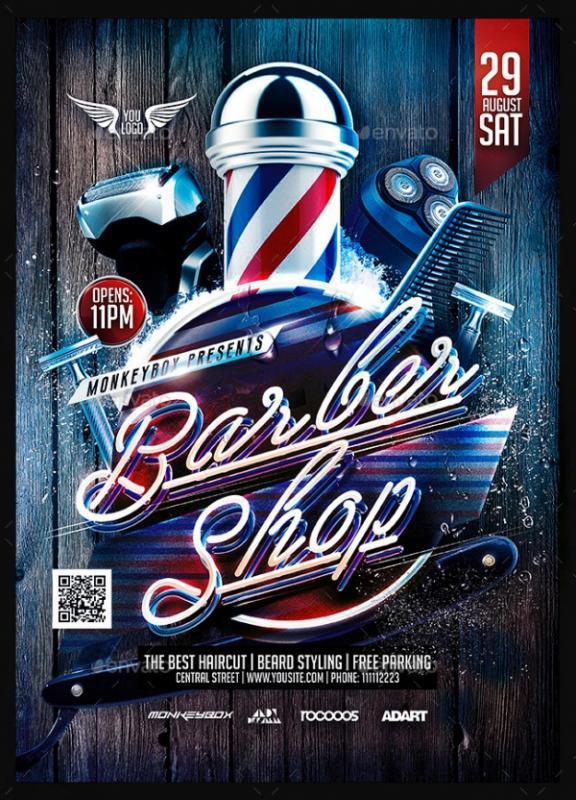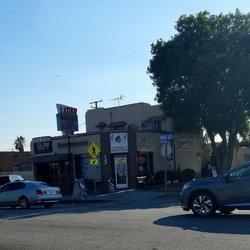The first image is the image on the left, the second image is the image on the right. Given the left and right images, does the statement "The combined images include two barber shop doors and two barber poles." hold true? Answer yes or no. Yes. The first image is the image on the left, the second image is the image on the right. Examine the images to the left and right. Is the description "In at least one image there are three people getting their haircut." accurate? Answer yes or no. No. 